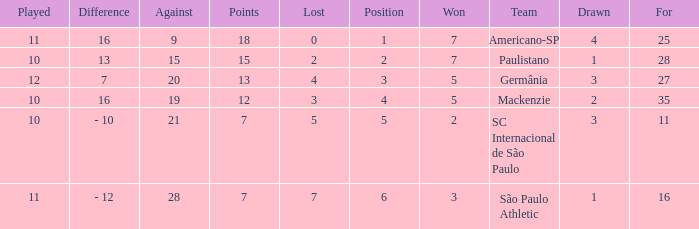Name the points for paulistano 15.0. 